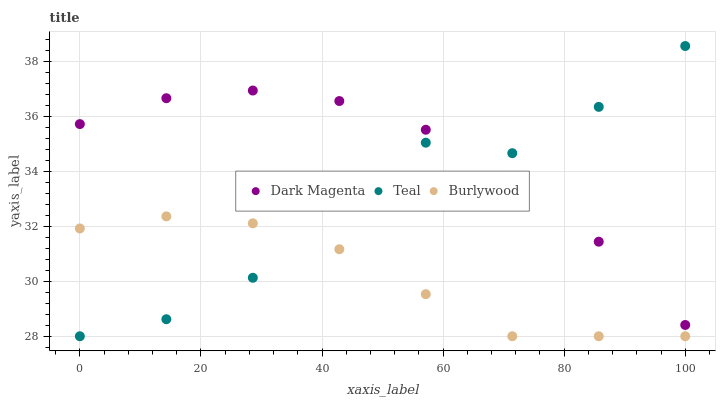Does Burlywood have the minimum area under the curve?
Answer yes or no. Yes. Does Dark Magenta have the maximum area under the curve?
Answer yes or no. Yes. Does Teal have the minimum area under the curve?
Answer yes or no. No. Does Teal have the maximum area under the curve?
Answer yes or no. No. Is Burlywood the smoothest?
Answer yes or no. Yes. Is Teal the roughest?
Answer yes or no. Yes. Is Dark Magenta the smoothest?
Answer yes or no. No. Is Dark Magenta the roughest?
Answer yes or no. No. Does Burlywood have the lowest value?
Answer yes or no. Yes. Does Dark Magenta have the lowest value?
Answer yes or no. No. Does Teal have the highest value?
Answer yes or no. Yes. Does Dark Magenta have the highest value?
Answer yes or no. No. Is Burlywood less than Dark Magenta?
Answer yes or no. Yes. Is Dark Magenta greater than Burlywood?
Answer yes or no. Yes. Does Dark Magenta intersect Teal?
Answer yes or no. Yes. Is Dark Magenta less than Teal?
Answer yes or no. No. Is Dark Magenta greater than Teal?
Answer yes or no. No. Does Burlywood intersect Dark Magenta?
Answer yes or no. No. 